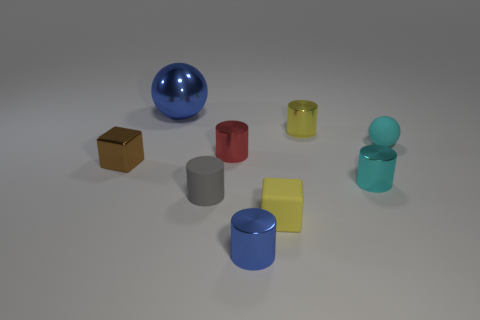There is a cylinder that is the same color as the big metallic sphere; what is its material?
Provide a succinct answer. Metal. There is a blue metal thing in front of the tiny brown block; does it have the same shape as the blue thing that is behind the brown shiny object?
Offer a terse response. No. Is there anything else that has the same size as the blue sphere?
Your answer should be very brief. No. How many cylinders are tiny brown shiny things or yellow metallic objects?
Your response must be concise. 1. Do the gray cylinder and the cyan cylinder have the same material?
Offer a very short reply. No. How many other things are there of the same color as the small matte sphere?
Provide a succinct answer. 1. What shape is the blue thing to the left of the rubber cylinder?
Provide a succinct answer. Sphere. How many objects are small cyan things or green matte cylinders?
Your response must be concise. 2. Is the size of the yellow cylinder the same as the blue thing behind the gray matte cylinder?
Keep it short and to the point. No. What number of other objects are there of the same material as the tiny brown block?
Offer a terse response. 5. 